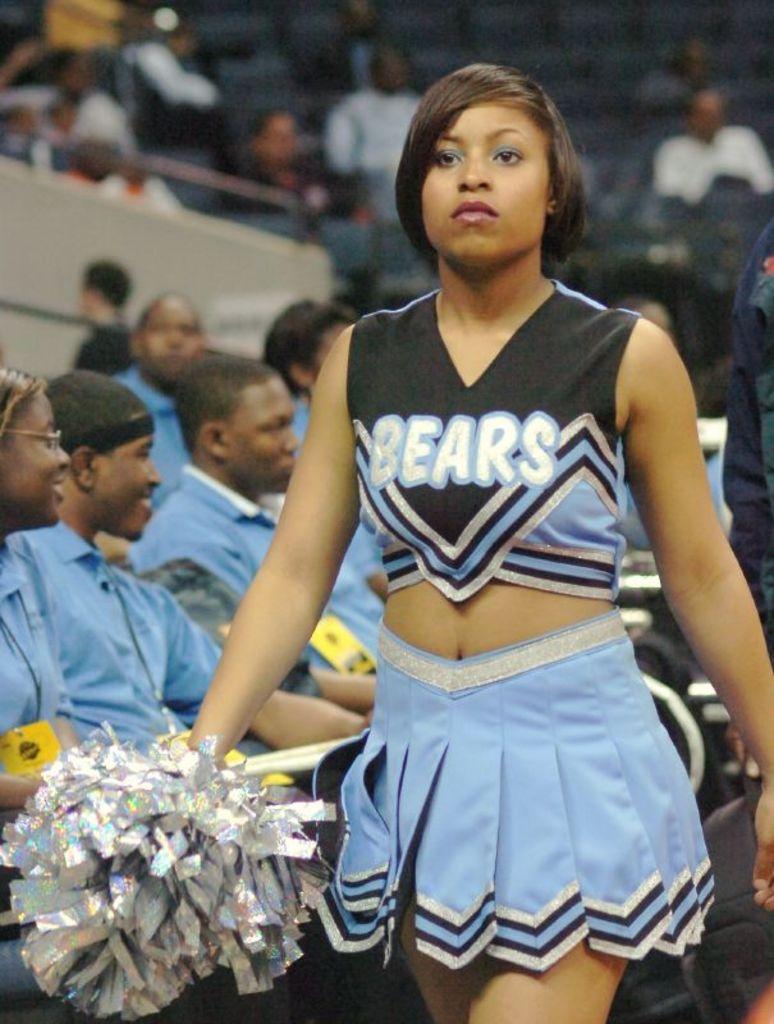What team has a blue and black cheer uniform?
Your answer should be very brief. Bears. 